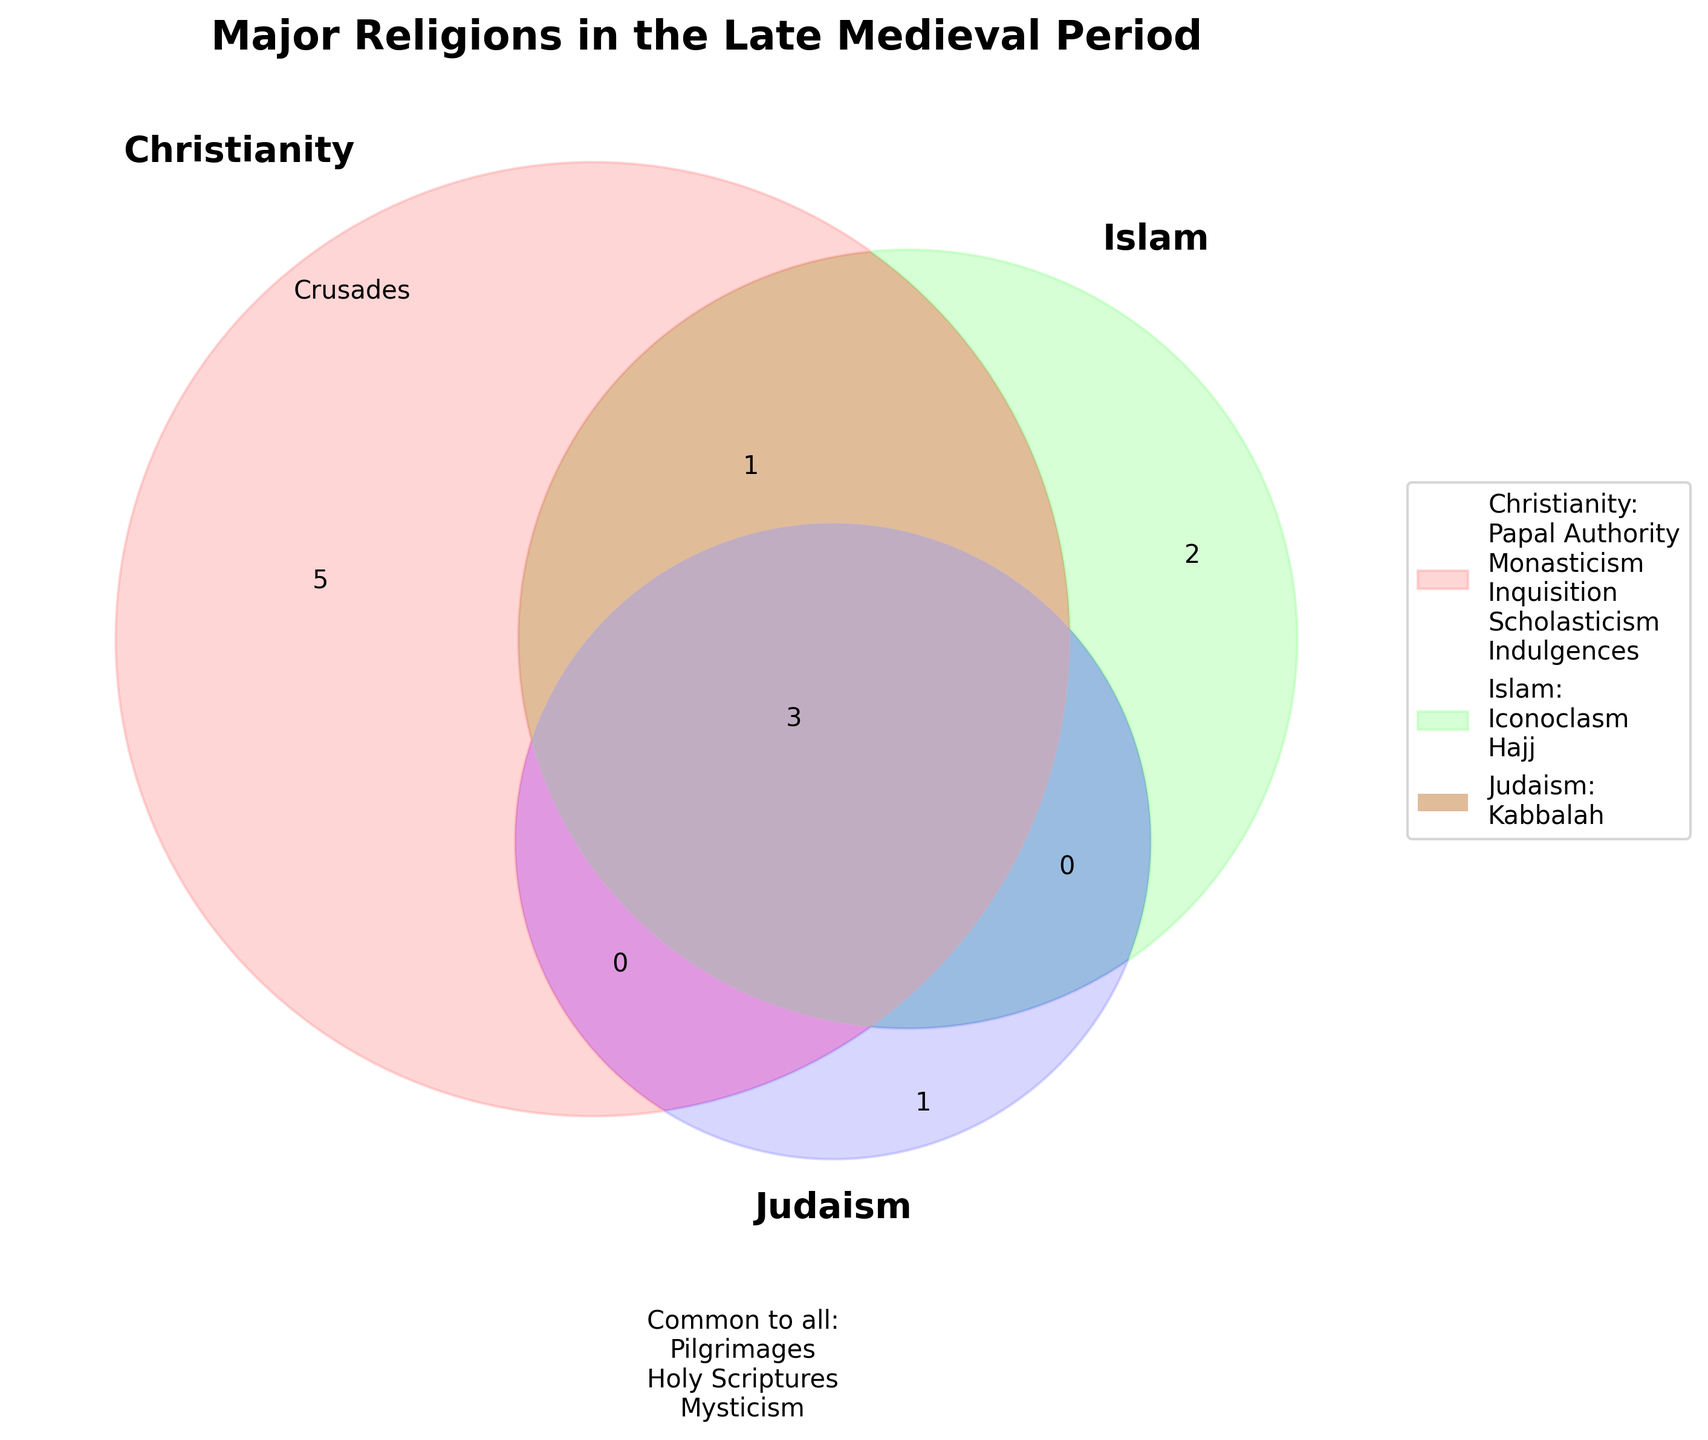What are the major religions shown in the title? The title of the figure states "Major Religions in the Late Medieval Period," which implies the three major religions being compared are Christianity, Islam, and Judaism.
Answer: Christianity, Islam, and Judaism Which unique practice or belief is only associated with Christianity? The legend and diagram indicate that Papal Authority, Monasticism, Inquisition, Scholasticism, and Indulgences are practices unique to Christianity.
Answer: Papal Authority, Monasticism, Inquisition, Scholasticism, Indulgences What practice is common to Christianity and Islam but not Judaism? The Venn diagram intersection between Christianity and Islam shows Crusades as a practice common to both but not to Judaism.
Answer: Crusades Which practices or beliefs are shared by all three religions? The text within the intersecting area for all three sets in the Venn diagram lists Pilgrimages, Holy Scriptures, and Mysticism as practices or beliefs shared by all three religions.
Answer: Pilgrimages, Holy Scriptures, Mysticism How many practices or beliefs are only found in Islam? The segment of the Venn diagram unique to Islam shows two practices or beliefs: Iconoclasm and Hajj.
Answer: 2 Which religion contains the practice of Kabbalah? The segment of the Venn diagram unique to Judaism mentions Kabbalah as a practice.
Answer: Judaism How does the number of unique practices or beliefs in Christianity compare to those in Islam? Christianity has five unique practices (Papal Authority, Monasticism, Inquisition, Scholasticism, Indulgences) while Islam has two (Iconoclasm, Hajj).
Answer: Christianity has more unique practices than Islam What shared aspect is indicated in the overlap between Christianity and Islam on the Venn diagram? The Venn diagram shows that the Crusades are common to both Christianity and Islam.
Answer: Crusades 